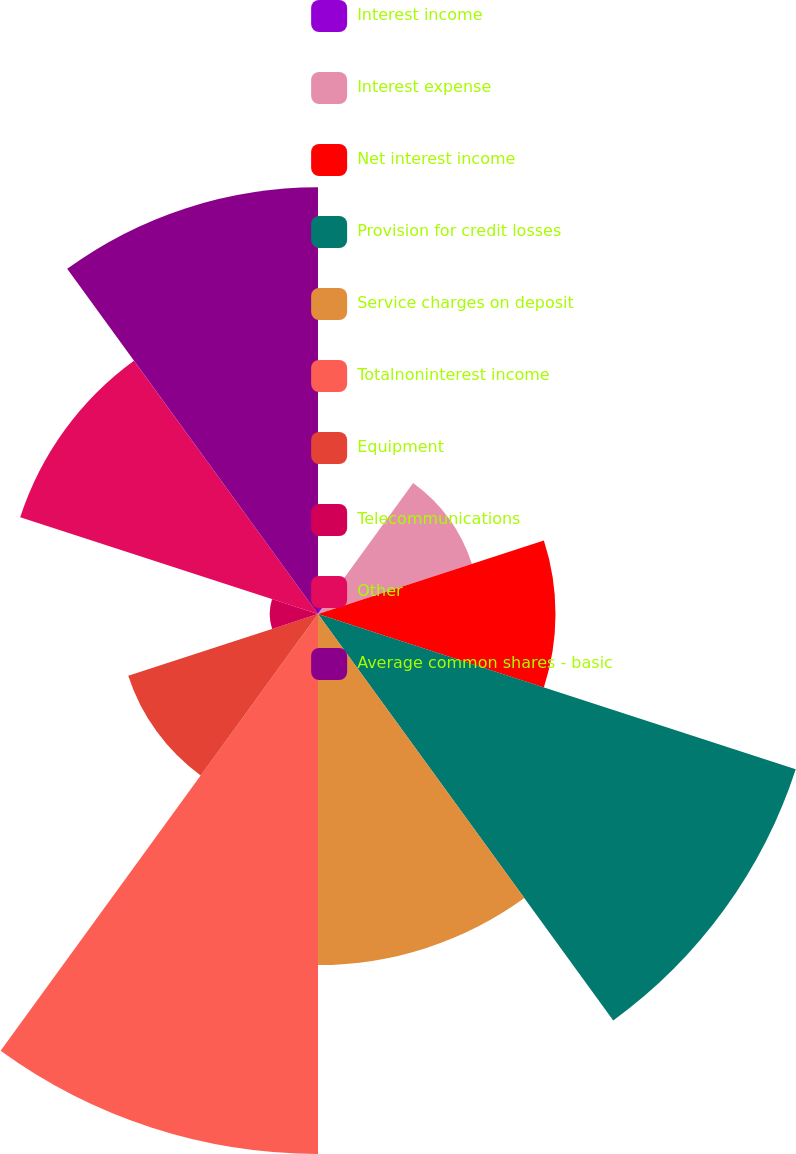Convert chart to OTSL. <chart><loc_0><loc_0><loc_500><loc_500><pie_chart><fcel>Interest income<fcel>Interest expense<fcel>Net interest income<fcel>Provision for credit losses<fcel>Service charges on deposit<fcel>Totalnoninterest income<fcel>Equipment<fcel>Telecommunications<fcel>Other<fcel>Average common shares - basic<nl><fcel>0.38%<fcel>5.8%<fcel>8.51%<fcel>18.0%<fcel>12.58%<fcel>19.35%<fcel>7.15%<fcel>1.73%<fcel>11.22%<fcel>15.29%<nl></chart> 